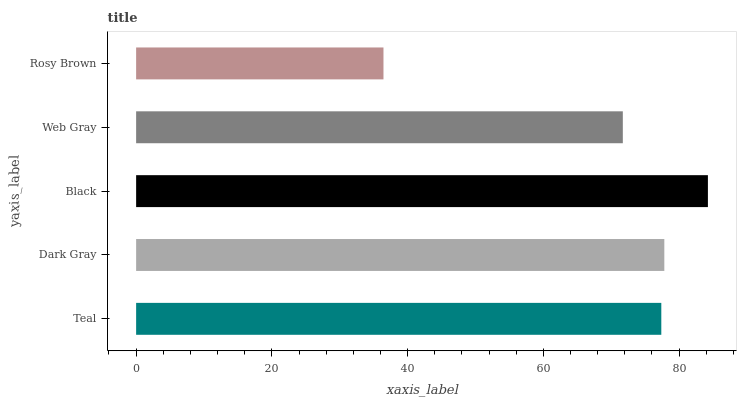Is Rosy Brown the minimum?
Answer yes or no. Yes. Is Black the maximum?
Answer yes or no. Yes. Is Dark Gray the minimum?
Answer yes or no. No. Is Dark Gray the maximum?
Answer yes or no. No. Is Dark Gray greater than Teal?
Answer yes or no. Yes. Is Teal less than Dark Gray?
Answer yes or no. Yes. Is Teal greater than Dark Gray?
Answer yes or no. No. Is Dark Gray less than Teal?
Answer yes or no. No. Is Teal the high median?
Answer yes or no. Yes. Is Teal the low median?
Answer yes or no. Yes. Is Black the high median?
Answer yes or no. No. Is Dark Gray the low median?
Answer yes or no. No. 